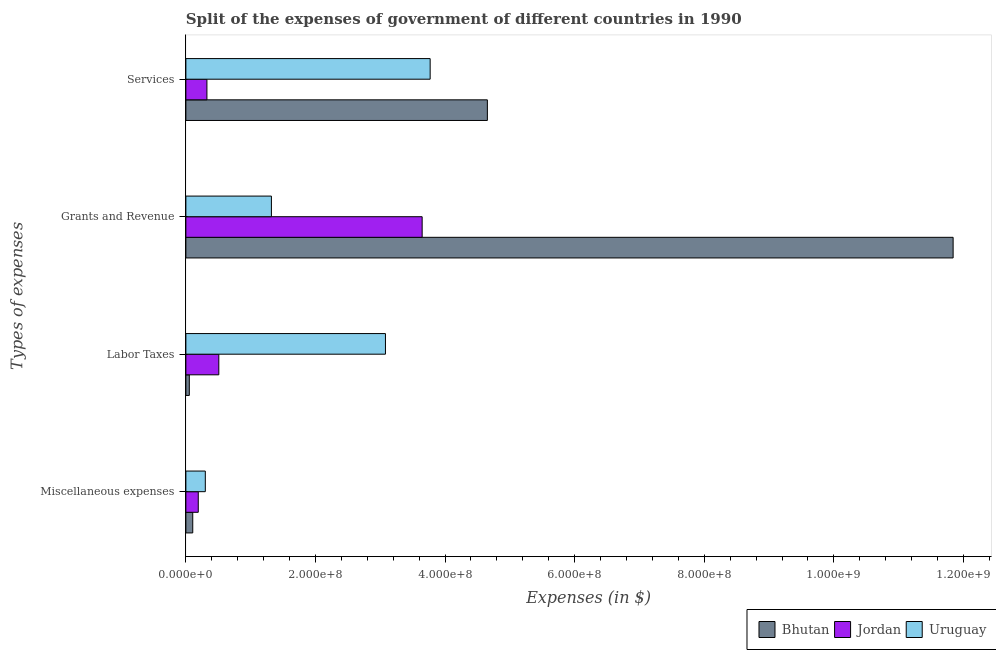How many different coloured bars are there?
Your answer should be compact. 3. How many groups of bars are there?
Your answer should be very brief. 4. Are the number of bars on each tick of the Y-axis equal?
Ensure brevity in your answer.  Yes. How many bars are there on the 3rd tick from the top?
Your response must be concise. 3. How many bars are there on the 3rd tick from the bottom?
Ensure brevity in your answer.  3. What is the label of the 3rd group of bars from the top?
Ensure brevity in your answer.  Labor Taxes. What is the amount spent on labor taxes in Uruguay?
Provide a succinct answer. 3.08e+08. Across all countries, what is the maximum amount spent on labor taxes?
Provide a short and direct response. 3.08e+08. Across all countries, what is the minimum amount spent on miscellaneous expenses?
Offer a very short reply. 1.06e+07. In which country was the amount spent on miscellaneous expenses maximum?
Give a very brief answer. Uruguay. In which country was the amount spent on grants and revenue minimum?
Make the answer very short. Uruguay. What is the total amount spent on miscellaneous expenses in the graph?
Provide a succinct answer. 5.97e+07. What is the difference between the amount spent on grants and revenue in Uruguay and that in Jordan?
Offer a terse response. -2.33e+08. What is the difference between the amount spent on grants and revenue in Jordan and the amount spent on services in Bhutan?
Ensure brevity in your answer.  -1.01e+08. What is the average amount spent on miscellaneous expenses per country?
Give a very brief answer. 1.99e+07. What is the difference between the amount spent on miscellaneous expenses and amount spent on grants and revenue in Bhutan?
Provide a short and direct response. -1.17e+09. In how many countries, is the amount spent on grants and revenue greater than 1080000000 $?
Keep it short and to the point. 1. What is the ratio of the amount spent on grants and revenue in Jordan to that in Bhutan?
Keep it short and to the point. 0.31. What is the difference between the highest and the second highest amount spent on labor taxes?
Ensure brevity in your answer.  2.57e+08. What is the difference between the highest and the lowest amount spent on services?
Ensure brevity in your answer.  4.33e+08. In how many countries, is the amount spent on miscellaneous expenses greater than the average amount spent on miscellaneous expenses taken over all countries?
Your answer should be compact. 1. Is the sum of the amount spent on labor taxes in Bhutan and Uruguay greater than the maximum amount spent on miscellaneous expenses across all countries?
Make the answer very short. Yes. Is it the case that in every country, the sum of the amount spent on services and amount spent on grants and revenue is greater than the sum of amount spent on labor taxes and amount spent on miscellaneous expenses?
Keep it short and to the point. No. What does the 1st bar from the top in Miscellaneous expenses represents?
Offer a terse response. Uruguay. What does the 2nd bar from the bottom in Grants and Revenue represents?
Your answer should be very brief. Jordan. Does the graph contain any zero values?
Offer a terse response. No. Does the graph contain grids?
Your answer should be compact. No. Where does the legend appear in the graph?
Give a very brief answer. Bottom right. How many legend labels are there?
Provide a short and direct response. 3. How are the legend labels stacked?
Give a very brief answer. Horizontal. What is the title of the graph?
Give a very brief answer. Split of the expenses of government of different countries in 1990. Does "Turkey" appear as one of the legend labels in the graph?
Your response must be concise. No. What is the label or title of the X-axis?
Make the answer very short. Expenses (in $). What is the label or title of the Y-axis?
Keep it short and to the point. Types of expenses. What is the Expenses (in $) in Bhutan in Miscellaneous expenses?
Your answer should be compact. 1.06e+07. What is the Expenses (in $) of Jordan in Miscellaneous expenses?
Offer a terse response. 1.91e+07. What is the Expenses (in $) in Uruguay in Miscellaneous expenses?
Ensure brevity in your answer.  3.00e+07. What is the Expenses (in $) in Bhutan in Labor Taxes?
Make the answer very short. 5.30e+06. What is the Expenses (in $) in Jordan in Labor Taxes?
Your answer should be compact. 5.08e+07. What is the Expenses (in $) in Uruguay in Labor Taxes?
Your response must be concise. 3.08e+08. What is the Expenses (in $) of Bhutan in Grants and Revenue?
Offer a terse response. 1.18e+09. What is the Expenses (in $) of Jordan in Grants and Revenue?
Your answer should be very brief. 3.65e+08. What is the Expenses (in $) of Uruguay in Grants and Revenue?
Ensure brevity in your answer.  1.32e+08. What is the Expenses (in $) in Bhutan in Services?
Your response must be concise. 4.65e+08. What is the Expenses (in $) in Jordan in Services?
Your response must be concise. 3.25e+07. What is the Expenses (in $) of Uruguay in Services?
Make the answer very short. 3.77e+08. Across all Types of expenses, what is the maximum Expenses (in $) of Bhutan?
Keep it short and to the point. 1.18e+09. Across all Types of expenses, what is the maximum Expenses (in $) of Jordan?
Your answer should be very brief. 3.65e+08. Across all Types of expenses, what is the maximum Expenses (in $) in Uruguay?
Provide a short and direct response. 3.77e+08. Across all Types of expenses, what is the minimum Expenses (in $) in Bhutan?
Your answer should be compact. 5.30e+06. Across all Types of expenses, what is the minimum Expenses (in $) in Jordan?
Keep it short and to the point. 1.91e+07. Across all Types of expenses, what is the minimum Expenses (in $) of Uruguay?
Make the answer very short. 3.00e+07. What is the total Expenses (in $) of Bhutan in the graph?
Your answer should be very brief. 1.67e+09. What is the total Expenses (in $) in Jordan in the graph?
Your answer should be very brief. 4.67e+08. What is the total Expenses (in $) of Uruguay in the graph?
Your response must be concise. 8.47e+08. What is the difference between the Expenses (in $) in Bhutan in Miscellaneous expenses and that in Labor Taxes?
Make the answer very short. 5.30e+06. What is the difference between the Expenses (in $) in Jordan in Miscellaneous expenses and that in Labor Taxes?
Offer a terse response. -3.17e+07. What is the difference between the Expenses (in $) in Uruguay in Miscellaneous expenses and that in Labor Taxes?
Offer a terse response. -2.78e+08. What is the difference between the Expenses (in $) in Bhutan in Miscellaneous expenses and that in Grants and Revenue?
Provide a short and direct response. -1.17e+09. What is the difference between the Expenses (in $) in Jordan in Miscellaneous expenses and that in Grants and Revenue?
Your answer should be very brief. -3.46e+08. What is the difference between the Expenses (in $) of Uruguay in Miscellaneous expenses and that in Grants and Revenue?
Provide a succinct answer. -1.02e+08. What is the difference between the Expenses (in $) in Bhutan in Miscellaneous expenses and that in Services?
Give a very brief answer. -4.55e+08. What is the difference between the Expenses (in $) in Jordan in Miscellaneous expenses and that in Services?
Your answer should be compact. -1.33e+07. What is the difference between the Expenses (in $) of Uruguay in Miscellaneous expenses and that in Services?
Keep it short and to the point. -3.47e+08. What is the difference between the Expenses (in $) in Bhutan in Labor Taxes and that in Grants and Revenue?
Your answer should be compact. -1.18e+09. What is the difference between the Expenses (in $) in Jordan in Labor Taxes and that in Grants and Revenue?
Make the answer very short. -3.14e+08. What is the difference between the Expenses (in $) of Uruguay in Labor Taxes and that in Grants and Revenue?
Keep it short and to the point. 1.76e+08. What is the difference between the Expenses (in $) in Bhutan in Labor Taxes and that in Services?
Your answer should be very brief. -4.60e+08. What is the difference between the Expenses (in $) in Jordan in Labor Taxes and that in Services?
Your answer should be very brief. 1.84e+07. What is the difference between the Expenses (in $) of Uruguay in Labor Taxes and that in Services?
Keep it short and to the point. -6.90e+07. What is the difference between the Expenses (in $) in Bhutan in Grants and Revenue and that in Services?
Offer a very short reply. 7.19e+08. What is the difference between the Expenses (in $) of Jordan in Grants and Revenue and that in Services?
Your answer should be compact. 3.32e+08. What is the difference between the Expenses (in $) of Uruguay in Grants and Revenue and that in Services?
Ensure brevity in your answer.  -2.45e+08. What is the difference between the Expenses (in $) of Bhutan in Miscellaneous expenses and the Expenses (in $) of Jordan in Labor Taxes?
Your answer should be very brief. -4.02e+07. What is the difference between the Expenses (in $) of Bhutan in Miscellaneous expenses and the Expenses (in $) of Uruguay in Labor Taxes?
Offer a very short reply. -2.97e+08. What is the difference between the Expenses (in $) in Jordan in Miscellaneous expenses and the Expenses (in $) in Uruguay in Labor Taxes?
Your answer should be very brief. -2.89e+08. What is the difference between the Expenses (in $) of Bhutan in Miscellaneous expenses and the Expenses (in $) of Jordan in Grants and Revenue?
Keep it short and to the point. -3.54e+08. What is the difference between the Expenses (in $) in Bhutan in Miscellaneous expenses and the Expenses (in $) in Uruguay in Grants and Revenue?
Provide a short and direct response. -1.21e+08. What is the difference between the Expenses (in $) in Jordan in Miscellaneous expenses and the Expenses (in $) in Uruguay in Grants and Revenue?
Give a very brief answer. -1.13e+08. What is the difference between the Expenses (in $) of Bhutan in Miscellaneous expenses and the Expenses (in $) of Jordan in Services?
Ensure brevity in your answer.  -2.19e+07. What is the difference between the Expenses (in $) in Bhutan in Miscellaneous expenses and the Expenses (in $) in Uruguay in Services?
Your answer should be compact. -3.66e+08. What is the difference between the Expenses (in $) in Jordan in Miscellaneous expenses and the Expenses (in $) in Uruguay in Services?
Your answer should be compact. -3.58e+08. What is the difference between the Expenses (in $) of Bhutan in Labor Taxes and the Expenses (in $) of Jordan in Grants and Revenue?
Offer a very short reply. -3.59e+08. What is the difference between the Expenses (in $) in Bhutan in Labor Taxes and the Expenses (in $) in Uruguay in Grants and Revenue?
Offer a very short reply. -1.27e+08. What is the difference between the Expenses (in $) of Jordan in Labor Taxes and the Expenses (in $) of Uruguay in Grants and Revenue?
Offer a terse response. -8.12e+07. What is the difference between the Expenses (in $) of Bhutan in Labor Taxes and the Expenses (in $) of Jordan in Services?
Keep it short and to the point. -2.72e+07. What is the difference between the Expenses (in $) of Bhutan in Labor Taxes and the Expenses (in $) of Uruguay in Services?
Make the answer very short. -3.72e+08. What is the difference between the Expenses (in $) in Jordan in Labor Taxes and the Expenses (in $) in Uruguay in Services?
Your response must be concise. -3.26e+08. What is the difference between the Expenses (in $) in Bhutan in Grants and Revenue and the Expenses (in $) in Jordan in Services?
Your answer should be very brief. 1.15e+09. What is the difference between the Expenses (in $) of Bhutan in Grants and Revenue and the Expenses (in $) of Uruguay in Services?
Provide a short and direct response. 8.07e+08. What is the difference between the Expenses (in $) in Jordan in Grants and Revenue and the Expenses (in $) in Uruguay in Services?
Give a very brief answer. -1.24e+07. What is the average Expenses (in $) of Bhutan per Types of expenses?
Ensure brevity in your answer.  4.16e+08. What is the average Expenses (in $) of Jordan per Types of expenses?
Give a very brief answer. 1.17e+08. What is the average Expenses (in $) of Uruguay per Types of expenses?
Provide a succinct answer. 2.12e+08. What is the difference between the Expenses (in $) in Bhutan and Expenses (in $) in Jordan in Miscellaneous expenses?
Give a very brief answer. -8.53e+06. What is the difference between the Expenses (in $) in Bhutan and Expenses (in $) in Uruguay in Miscellaneous expenses?
Make the answer very short. -1.94e+07. What is the difference between the Expenses (in $) in Jordan and Expenses (in $) in Uruguay in Miscellaneous expenses?
Keep it short and to the point. -1.09e+07. What is the difference between the Expenses (in $) in Bhutan and Expenses (in $) in Jordan in Labor Taxes?
Your answer should be compact. -4.55e+07. What is the difference between the Expenses (in $) in Bhutan and Expenses (in $) in Uruguay in Labor Taxes?
Your answer should be compact. -3.03e+08. What is the difference between the Expenses (in $) in Jordan and Expenses (in $) in Uruguay in Labor Taxes?
Provide a short and direct response. -2.57e+08. What is the difference between the Expenses (in $) of Bhutan and Expenses (in $) of Jordan in Grants and Revenue?
Give a very brief answer. 8.19e+08. What is the difference between the Expenses (in $) in Bhutan and Expenses (in $) in Uruguay in Grants and Revenue?
Make the answer very short. 1.05e+09. What is the difference between the Expenses (in $) in Jordan and Expenses (in $) in Uruguay in Grants and Revenue?
Offer a very short reply. 2.33e+08. What is the difference between the Expenses (in $) of Bhutan and Expenses (in $) of Jordan in Services?
Your answer should be very brief. 4.33e+08. What is the difference between the Expenses (in $) in Bhutan and Expenses (in $) in Uruguay in Services?
Your answer should be compact. 8.83e+07. What is the difference between the Expenses (in $) of Jordan and Expenses (in $) of Uruguay in Services?
Provide a short and direct response. -3.45e+08. What is the ratio of the Expenses (in $) of Jordan in Miscellaneous expenses to that in Labor Taxes?
Your response must be concise. 0.38. What is the ratio of the Expenses (in $) of Uruguay in Miscellaneous expenses to that in Labor Taxes?
Ensure brevity in your answer.  0.1. What is the ratio of the Expenses (in $) in Bhutan in Miscellaneous expenses to that in Grants and Revenue?
Offer a terse response. 0.01. What is the ratio of the Expenses (in $) of Jordan in Miscellaneous expenses to that in Grants and Revenue?
Offer a terse response. 0.05. What is the ratio of the Expenses (in $) of Uruguay in Miscellaneous expenses to that in Grants and Revenue?
Your answer should be very brief. 0.23. What is the ratio of the Expenses (in $) in Bhutan in Miscellaneous expenses to that in Services?
Offer a very short reply. 0.02. What is the ratio of the Expenses (in $) of Jordan in Miscellaneous expenses to that in Services?
Ensure brevity in your answer.  0.59. What is the ratio of the Expenses (in $) of Uruguay in Miscellaneous expenses to that in Services?
Offer a very short reply. 0.08. What is the ratio of the Expenses (in $) in Bhutan in Labor Taxes to that in Grants and Revenue?
Provide a succinct answer. 0. What is the ratio of the Expenses (in $) of Jordan in Labor Taxes to that in Grants and Revenue?
Provide a succinct answer. 0.14. What is the ratio of the Expenses (in $) of Uruguay in Labor Taxes to that in Grants and Revenue?
Provide a succinct answer. 2.33. What is the ratio of the Expenses (in $) of Bhutan in Labor Taxes to that in Services?
Ensure brevity in your answer.  0.01. What is the ratio of the Expenses (in $) in Jordan in Labor Taxes to that in Services?
Provide a short and direct response. 1.57. What is the ratio of the Expenses (in $) of Uruguay in Labor Taxes to that in Services?
Provide a short and direct response. 0.82. What is the ratio of the Expenses (in $) in Bhutan in Grants and Revenue to that in Services?
Your answer should be very brief. 2.54. What is the ratio of the Expenses (in $) in Jordan in Grants and Revenue to that in Services?
Your answer should be very brief. 11.23. What is the ratio of the Expenses (in $) of Uruguay in Grants and Revenue to that in Services?
Keep it short and to the point. 0.35. What is the difference between the highest and the second highest Expenses (in $) of Bhutan?
Your answer should be compact. 7.19e+08. What is the difference between the highest and the second highest Expenses (in $) of Jordan?
Your response must be concise. 3.14e+08. What is the difference between the highest and the second highest Expenses (in $) in Uruguay?
Offer a very short reply. 6.90e+07. What is the difference between the highest and the lowest Expenses (in $) in Bhutan?
Your response must be concise. 1.18e+09. What is the difference between the highest and the lowest Expenses (in $) of Jordan?
Your answer should be compact. 3.46e+08. What is the difference between the highest and the lowest Expenses (in $) in Uruguay?
Your answer should be very brief. 3.47e+08. 